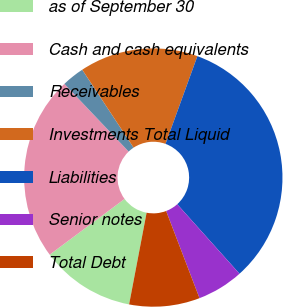<chart> <loc_0><loc_0><loc_500><loc_500><pie_chart><fcel>as of September 30<fcel>Cash and cash equivalents<fcel>Receivables<fcel>Investments Total Liquid<fcel>Liabilities<fcel>Senior notes<fcel>Total Debt<nl><fcel>11.82%<fcel>23.1%<fcel>2.81%<fcel>14.82%<fcel>32.83%<fcel>5.81%<fcel>8.82%<nl></chart> 